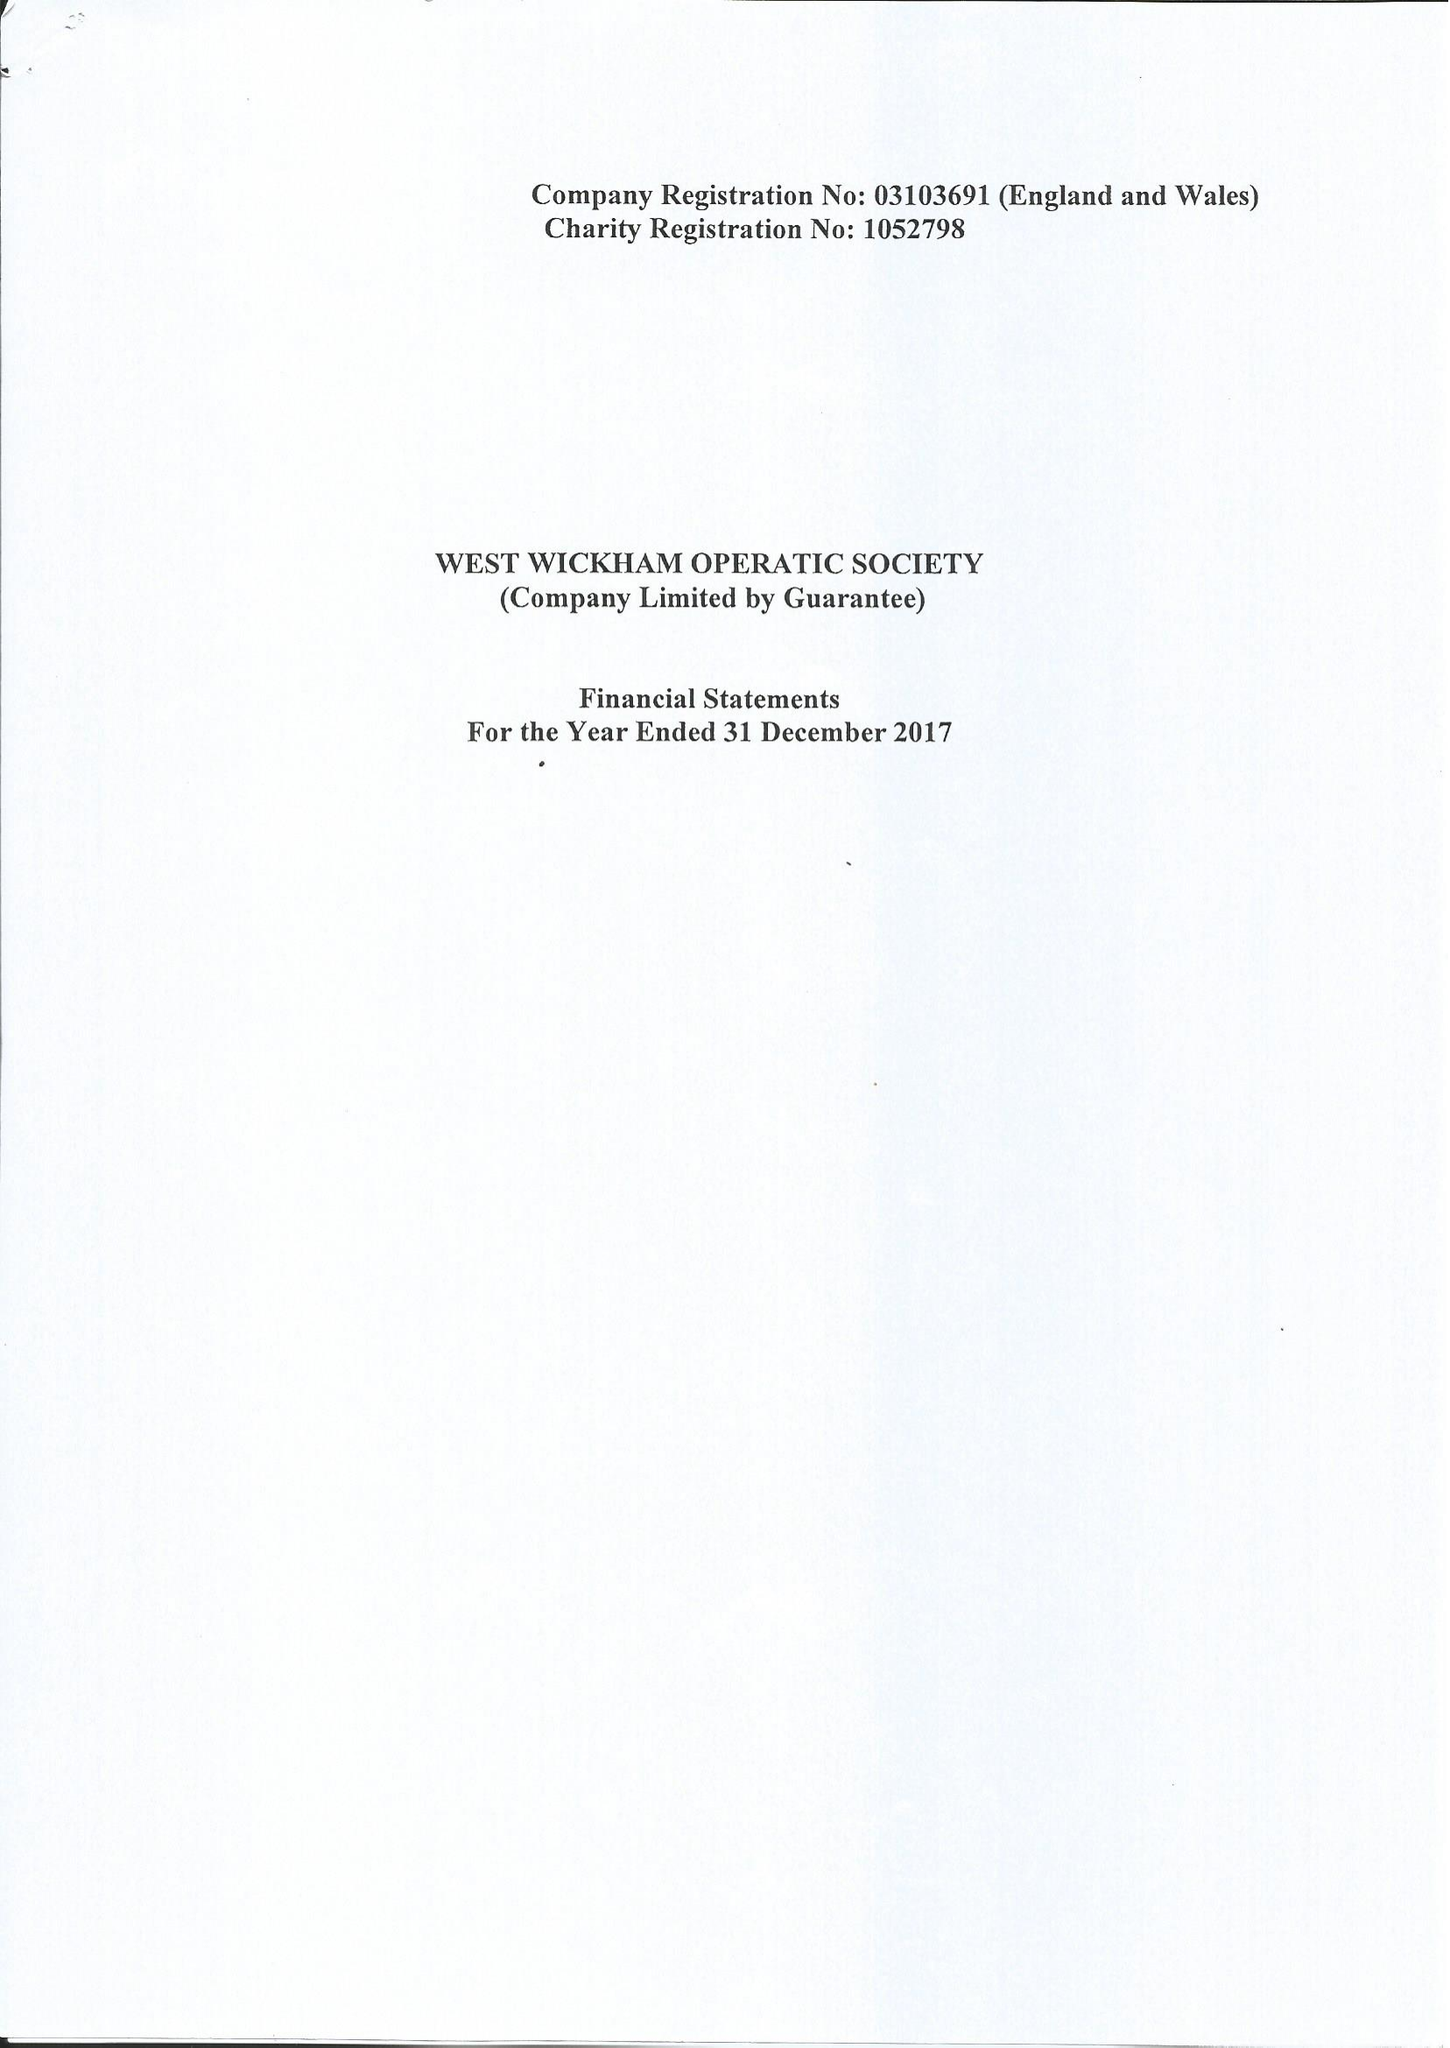What is the value for the income_annually_in_british_pounds?
Answer the question using a single word or phrase. 183261.00 